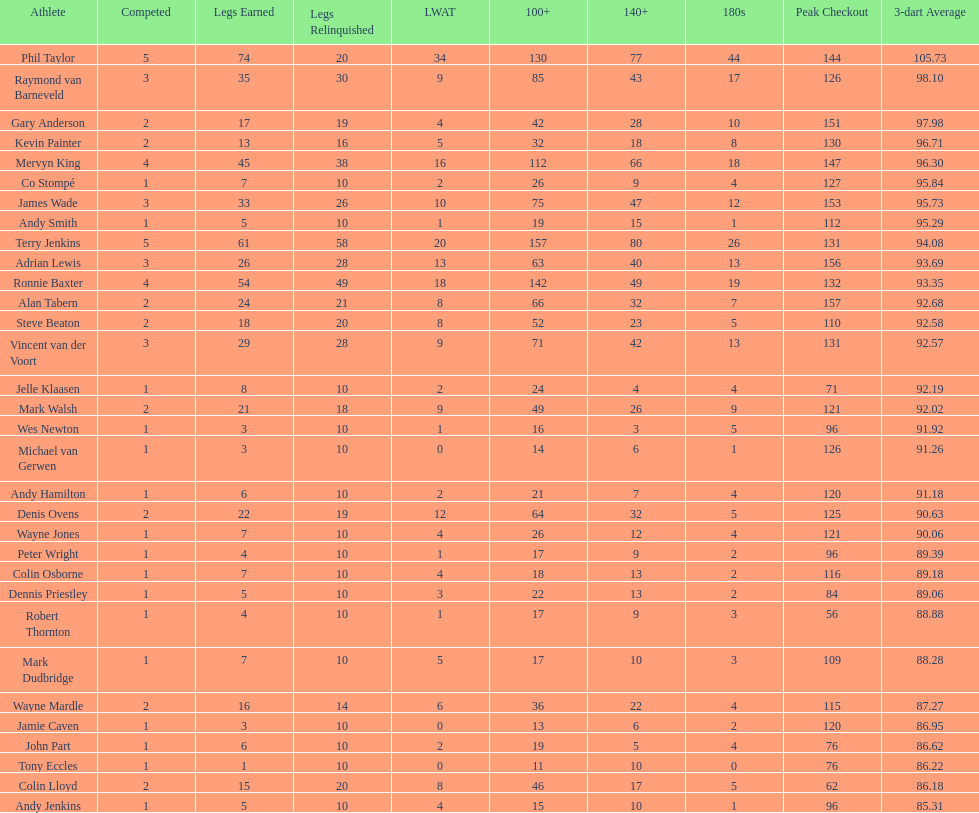Which player has a high checkout of 116? Colin Osborne. 